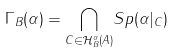Convert formula to latex. <formula><loc_0><loc_0><loc_500><loc_500>\Gamma _ { B } ( \alpha ) = \underset { C \in \mathcal { H } _ { B } ^ { \alpha } ( A ) } { \bigcap } S p ( \alpha | _ { C } )</formula> 